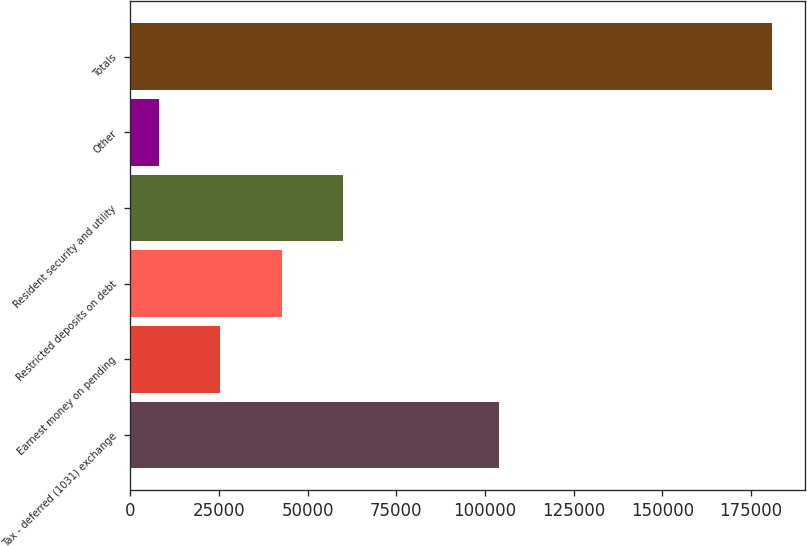Convert chart. <chart><loc_0><loc_0><loc_500><loc_500><bar_chart><fcel>Tax - deferred (1031) exchange<fcel>Earnest money on pending<fcel>Restricted deposits on debt<fcel>Resident security and utility<fcel>Other<fcel>Totals<nl><fcel>103887<fcel>25411.2<fcel>42697.4<fcel>59983.6<fcel>8125<fcel>180987<nl></chart> 